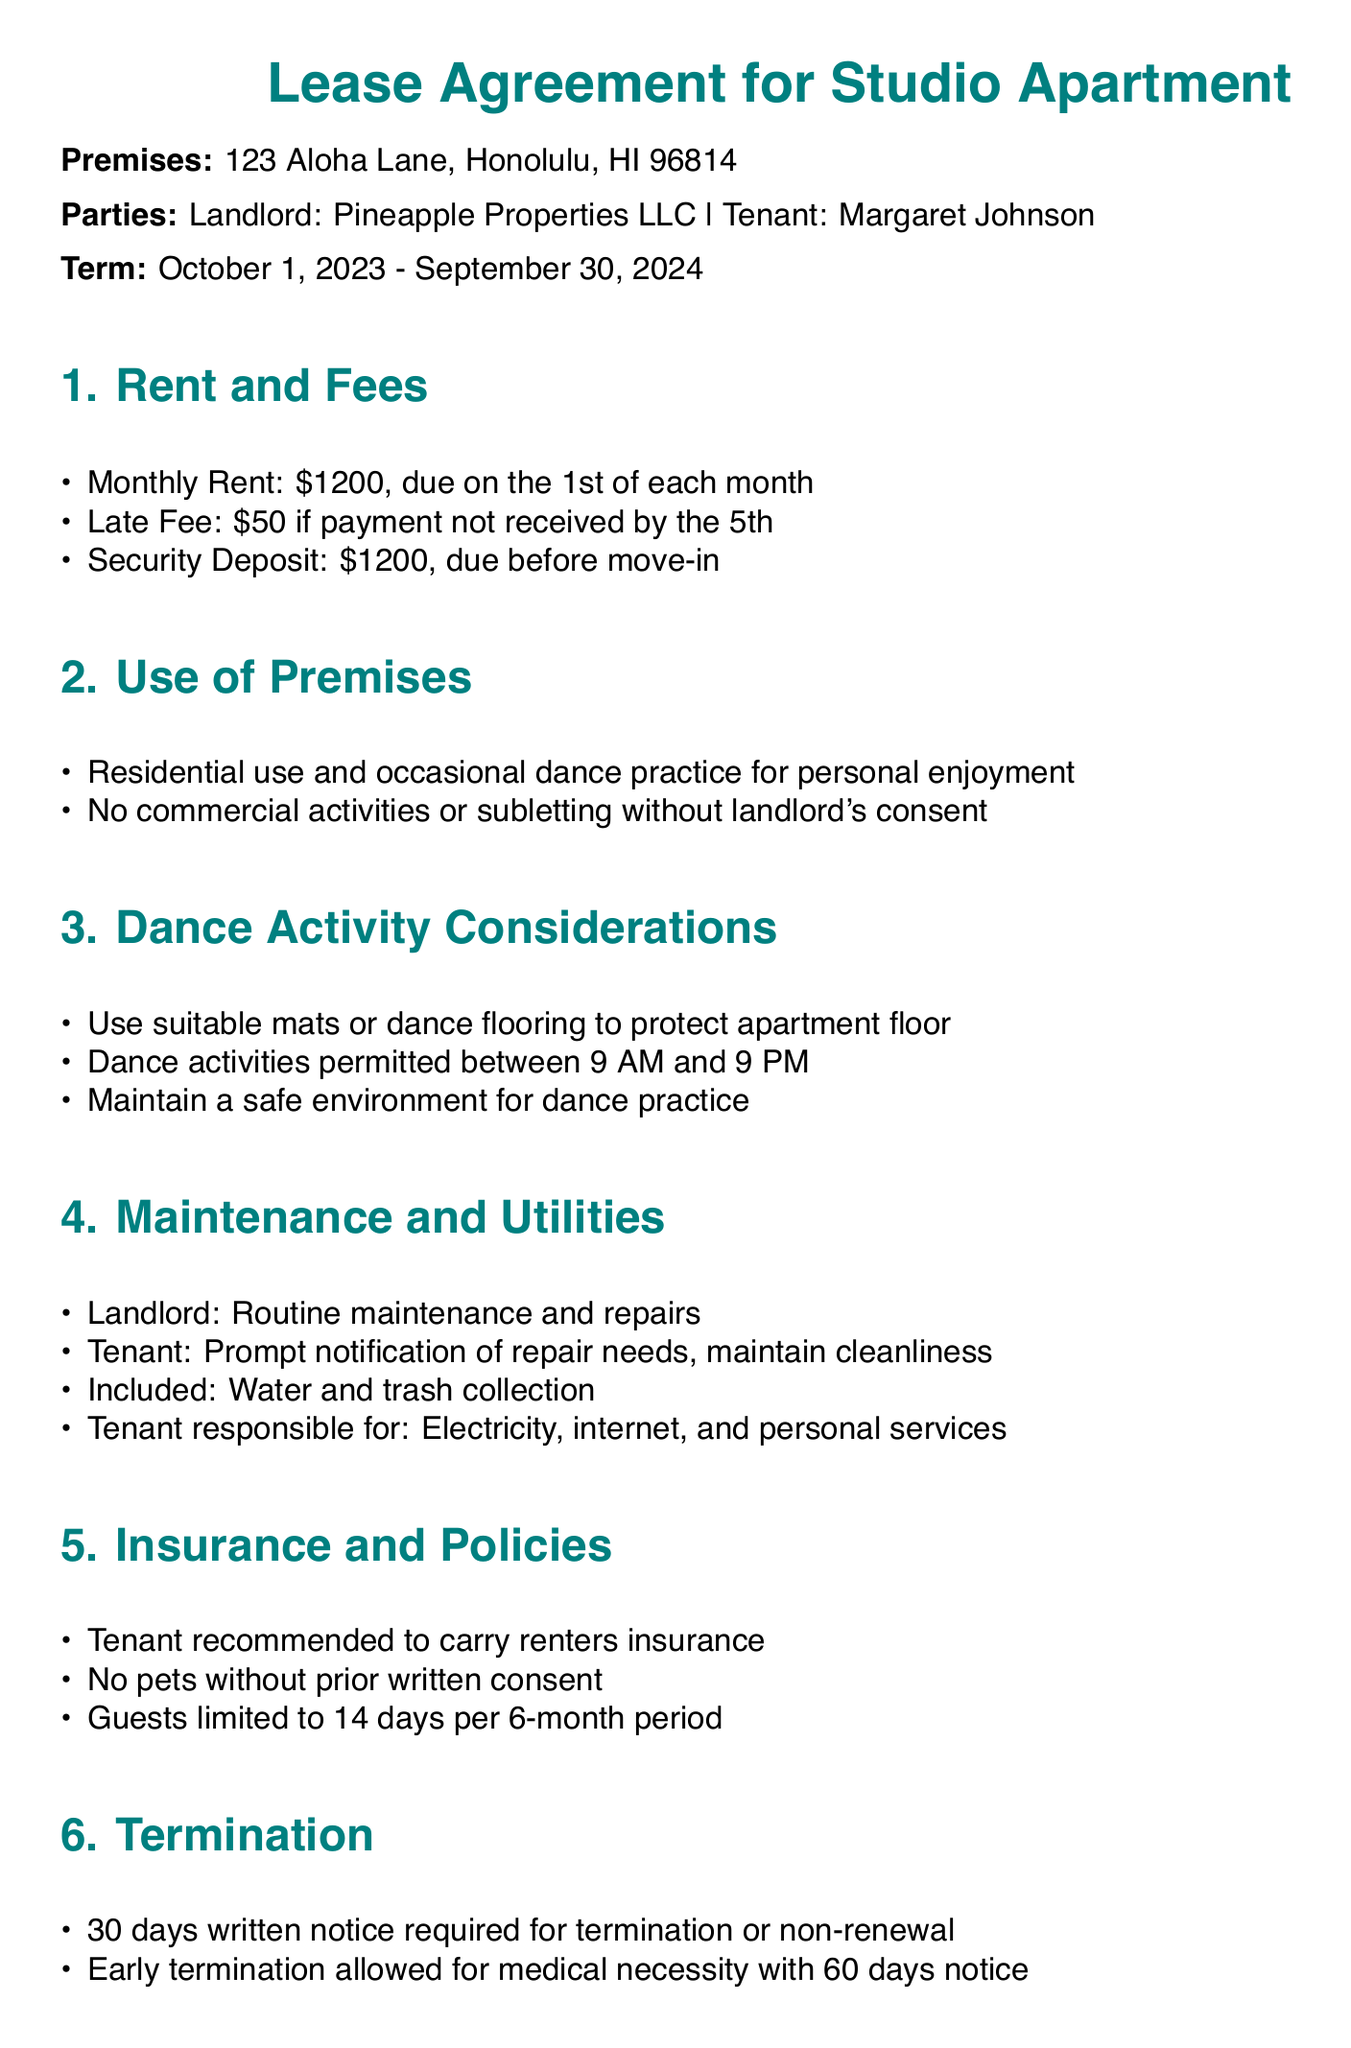What is the monthly rent for the studio apartment? The monthly rent is specified in the document as $1200.
Answer: $1200 What is the security deposit amount? The security deposit amount is stated in the agreement as $1200, due before move-in.
Answer: $1200 What activities are permitted in the premises? The document specifies that residential use and occasional dance practice for personal enjoyment are permitted.
Answer: Residential use and occasional dance practice What are the hours during which dance activities are allowed? The lease agreement indicates that dance activities are permitted between 9 AM and 9 PM.
Answer: 9 AM and 9 PM What is required for early termination for medical necessity? The document states that 60 days written notice is required for early termination due to medical necessity.
Answer: 60 days written notice Who is responsible for maintaining cleanliness? The agreement specifies that the tenant is responsible for maintaining cleanliness.
Answer: Tenant Is renters insurance recommended? The document mentions that it is recommended for the tenant to carry renters insurance.
Answer: Yes How long can guests stay in the apartment? The agreement limits guests to 14 days per 6-month period.
Answer: 14 days What is the late fee for late rent payment? The late fee for late rent payment is stated as $50 if payment is not received by the 5th.
Answer: $50 